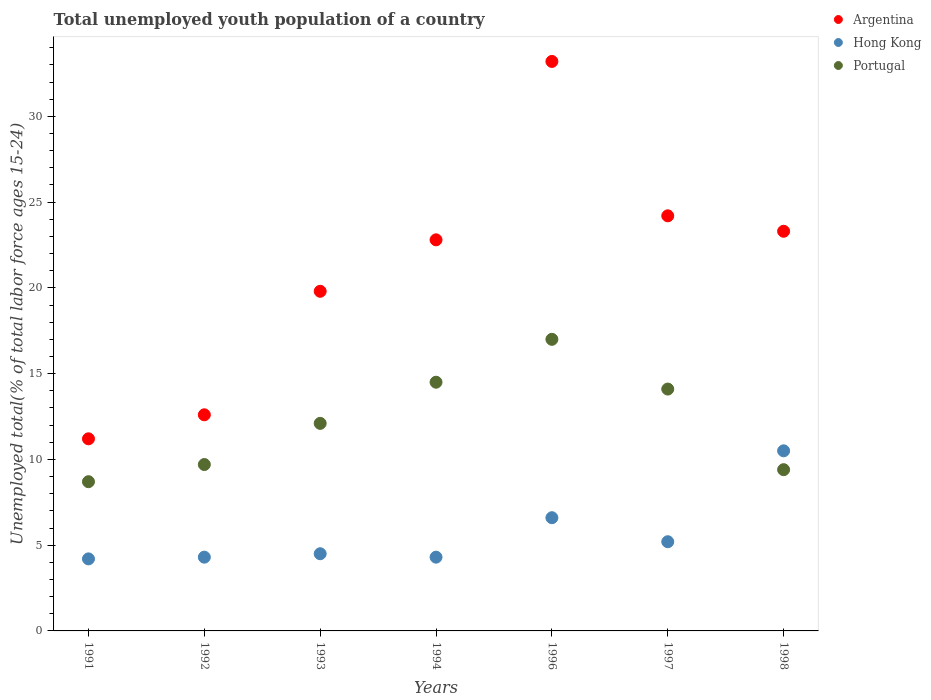How many different coloured dotlines are there?
Make the answer very short. 3. Is the number of dotlines equal to the number of legend labels?
Keep it short and to the point. Yes. What is the percentage of total unemployed youth population of a country in Argentina in 1992?
Offer a very short reply. 12.6. Across all years, what is the maximum percentage of total unemployed youth population of a country in Argentina?
Your response must be concise. 33.2. Across all years, what is the minimum percentage of total unemployed youth population of a country in Argentina?
Keep it short and to the point. 11.2. In which year was the percentage of total unemployed youth population of a country in Portugal maximum?
Provide a short and direct response. 1996. What is the total percentage of total unemployed youth population of a country in Portugal in the graph?
Your answer should be very brief. 85.5. What is the difference between the percentage of total unemployed youth population of a country in Argentina in 1992 and that in 1998?
Keep it short and to the point. -10.7. What is the difference between the percentage of total unemployed youth population of a country in Portugal in 1993 and the percentage of total unemployed youth population of a country in Hong Kong in 1996?
Offer a terse response. 5.5. What is the average percentage of total unemployed youth population of a country in Hong Kong per year?
Your response must be concise. 5.66. In the year 1997, what is the difference between the percentage of total unemployed youth population of a country in Hong Kong and percentage of total unemployed youth population of a country in Portugal?
Your response must be concise. -8.9. In how many years, is the percentage of total unemployed youth population of a country in Argentina greater than 11 %?
Give a very brief answer. 7. What is the ratio of the percentage of total unemployed youth population of a country in Argentina in 1994 to that in 1998?
Offer a terse response. 0.98. What is the difference between the highest and the second highest percentage of total unemployed youth population of a country in Argentina?
Provide a succinct answer. 9. What is the difference between the highest and the lowest percentage of total unemployed youth population of a country in Hong Kong?
Give a very brief answer. 6.3. In how many years, is the percentage of total unemployed youth population of a country in Portugal greater than the average percentage of total unemployed youth population of a country in Portugal taken over all years?
Your answer should be very brief. 3. Is the sum of the percentage of total unemployed youth population of a country in Portugal in 1992 and 1998 greater than the maximum percentage of total unemployed youth population of a country in Argentina across all years?
Provide a short and direct response. No. Is it the case that in every year, the sum of the percentage of total unemployed youth population of a country in Hong Kong and percentage of total unemployed youth population of a country in Portugal  is greater than the percentage of total unemployed youth population of a country in Argentina?
Provide a short and direct response. No. How many dotlines are there?
Offer a very short reply. 3. What is the difference between two consecutive major ticks on the Y-axis?
Provide a succinct answer. 5. Where does the legend appear in the graph?
Provide a short and direct response. Top right. What is the title of the graph?
Your answer should be compact. Total unemployed youth population of a country. What is the label or title of the X-axis?
Your response must be concise. Years. What is the label or title of the Y-axis?
Provide a short and direct response. Unemployed total(% of total labor force ages 15-24). What is the Unemployed total(% of total labor force ages 15-24) of Argentina in 1991?
Ensure brevity in your answer.  11.2. What is the Unemployed total(% of total labor force ages 15-24) in Hong Kong in 1991?
Ensure brevity in your answer.  4.2. What is the Unemployed total(% of total labor force ages 15-24) in Portugal in 1991?
Your answer should be compact. 8.7. What is the Unemployed total(% of total labor force ages 15-24) in Argentina in 1992?
Give a very brief answer. 12.6. What is the Unemployed total(% of total labor force ages 15-24) in Hong Kong in 1992?
Your answer should be very brief. 4.3. What is the Unemployed total(% of total labor force ages 15-24) of Portugal in 1992?
Offer a very short reply. 9.7. What is the Unemployed total(% of total labor force ages 15-24) in Argentina in 1993?
Give a very brief answer. 19.8. What is the Unemployed total(% of total labor force ages 15-24) of Portugal in 1993?
Make the answer very short. 12.1. What is the Unemployed total(% of total labor force ages 15-24) in Argentina in 1994?
Offer a terse response. 22.8. What is the Unemployed total(% of total labor force ages 15-24) of Hong Kong in 1994?
Your answer should be very brief. 4.3. What is the Unemployed total(% of total labor force ages 15-24) in Portugal in 1994?
Your answer should be very brief. 14.5. What is the Unemployed total(% of total labor force ages 15-24) of Argentina in 1996?
Offer a very short reply. 33.2. What is the Unemployed total(% of total labor force ages 15-24) of Hong Kong in 1996?
Provide a short and direct response. 6.6. What is the Unemployed total(% of total labor force ages 15-24) in Argentina in 1997?
Give a very brief answer. 24.2. What is the Unemployed total(% of total labor force ages 15-24) of Hong Kong in 1997?
Offer a very short reply. 5.2. What is the Unemployed total(% of total labor force ages 15-24) in Portugal in 1997?
Provide a succinct answer. 14.1. What is the Unemployed total(% of total labor force ages 15-24) of Argentina in 1998?
Ensure brevity in your answer.  23.3. What is the Unemployed total(% of total labor force ages 15-24) in Portugal in 1998?
Make the answer very short. 9.4. Across all years, what is the maximum Unemployed total(% of total labor force ages 15-24) of Argentina?
Your answer should be compact. 33.2. Across all years, what is the maximum Unemployed total(% of total labor force ages 15-24) of Hong Kong?
Your response must be concise. 10.5. Across all years, what is the maximum Unemployed total(% of total labor force ages 15-24) in Portugal?
Your response must be concise. 17. Across all years, what is the minimum Unemployed total(% of total labor force ages 15-24) in Argentina?
Give a very brief answer. 11.2. Across all years, what is the minimum Unemployed total(% of total labor force ages 15-24) in Hong Kong?
Your response must be concise. 4.2. Across all years, what is the minimum Unemployed total(% of total labor force ages 15-24) in Portugal?
Ensure brevity in your answer.  8.7. What is the total Unemployed total(% of total labor force ages 15-24) in Argentina in the graph?
Ensure brevity in your answer.  147.1. What is the total Unemployed total(% of total labor force ages 15-24) in Hong Kong in the graph?
Give a very brief answer. 39.6. What is the total Unemployed total(% of total labor force ages 15-24) of Portugal in the graph?
Provide a short and direct response. 85.5. What is the difference between the Unemployed total(% of total labor force ages 15-24) of Argentina in 1991 and that in 1992?
Provide a short and direct response. -1.4. What is the difference between the Unemployed total(% of total labor force ages 15-24) in Argentina in 1991 and that in 1993?
Provide a short and direct response. -8.6. What is the difference between the Unemployed total(% of total labor force ages 15-24) of Portugal in 1991 and that in 1993?
Make the answer very short. -3.4. What is the difference between the Unemployed total(% of total labor force ages 15-24) of Argentina in 1991 and that in 1994?
Your answer should be very brief. -11.6. What is the difference between the Unemployed total(% of total labor force ages 15-24) in Portugal in 1991 and that in 1994?
Offer a very short reply. -5.8. What is the difference between the Unemployed total(% of total labor force ages 15-24) of Argentina in 1991 and that in 1997?
Keep it short and to the point. -13. What is the difference between the Unemployed total(% of total labor force ages 15-24) in Portugal in 1991 and that in 1998?
Ensure brevity in your answer.  -0.7. What is the difference between the Unemployed total(% of total labor force ages 15-24) in Portugal in 1992 and that in 1993?
Provide a succinct answer. -2.4. What is the difference between the Unemployed total(% of total labor force ages 15-24) in Hong Kong in 1992 and that in 1994?
Offer a very short reply. 0. What is the difference between the Unemployed total(% of total labor force ages 15-24) in Argentina in 1992 and that in 1996?
Provide a short and direct response. -20.6. What is the difference between the Unemployed total(% of total labor force ages 15-24) in Hong Kong in 1992 and that in 1996?
Your answer should be very brief. -2.3. What is the difference between the Unemployed total(% of total labor force ages 15-24) of Portugal in 1992 and that in 1996?
Ensure brevity in your answer.  -7.3. What is the difference between the Unemployed total(% of total labor force ages 15-24) in Argentina in 1992 and that in 1997?
Provide a short and direct response. -11.6. What is the difference between the Unemployed total(% of total labor force ages 15-24) of Argentina in 1992 and that in 1998?
Keep it short and to the point. -10.7. What is the difference between the Unemployed total(% of total labor force ages 15-24) in Hong Kong in 1992 and that in 1998?
Offer a very short reply. -6.2. What is the difference between the Unemployed total(% of total labor force ages 15-24) in Portugal in 1992 and that in 1998?
Your response must be concise. 0.3. What is the difference between the Unemployed total(% of total labor force ages 15-24) in Argentina in 1993 and that in 1994?
Offer a terse response. -3. What is the difference between the Unemployed total(% of total labor force ages 15-24) in Argentina in 1993 and that in 1996?
Your answer should be compact. -13.4. What is the difference between the Unemployed total(% of total labor force ages 15-24) in Portugal in 1993 and that in 1996?
Offer a terse response. -4.9. What is the difference between the Unemployed total(% of total labor force ages 15-24) of Hong Kong in 1993 and that in 1997?
Provide a succinct answer. -0.7. What is the difference between the Unemployed total(% of total labor force ages 15-24) of Hong Kong in 1993 and that in 1998?
Your response must be concise. -6. What is the difference between the Unemployed total(% of total labor force ages 15-24) of Hong Kong in 1994 and that in 1996?
Your answer should be very brief. -2.3. What is the difference between the Unemployed total(% of total labor force ages 15-24) of Hong Kong in 1994 and that in 1997?
Your response must be concise. -0.9. What is the difference between the Unemployed total(% of total labor force ages 15-24) in Argentina in 1994 and that in 1998?
Ensure brevity in your answer.  -0.5. What is the difference between the Unemployed total(% of total labor force ages 15-24) in Hong Kong in 1994 and that in 1998?
Provide a short and direct response. -6.2. What is the difference between the Unemployed total(% of total labor force ages 15-24) of Argentina in 1996 and that in 1998?
Provide a short and direct response. 9.9. What is the difference between the Unemployed total(% of total labor force ages 15-24) of Hong Kong in 1996 and that in 1998?
Provide a succinct answer. -3.9. What is the difference between the Unemployed total(% of total labor force ages 15-24) in Argentina in 1997 and that in 1998?
Provide a short and direct response. 0.9. What is the difference between the Unemployed total(% of total labor force ages 15-24) of Hong Kong in 1991 and the Unemployed total(% of total labor force ages 15-24) of Portugal in 1992?
Your answer should be very brief. -5.5. What is the difference between the Unemployed total(% of total labor force ages 15-24) in Argentina in 1991 and the Unemployed total(% of total labor force ages 15-24) in Portugal in 1993?
Make the answer very short. -0.9. What is the difference between the Unemployed total(% of total labor force ages 15-24) of Argentina in 1991 and the Unemployed total(% of total labor force ages 15-24) of Hong Kong in 1994?
Give a very brief answer. 6.9. What is the difference between the Unemployed total(% of total labor force ages 15-24) of Argentina in 1991 and the Unemployed total(% of total labor force ages 15-24) of Hong Kong in 1997?
Make the answer very short. 6. What is the difference between the Unemployed total(% of total labor force ages 15-24) of Argentina in 1991 and the Unemployed total(% of total labor force ages 15-24) of Portugal in 1998?
Your answer should be very brief. 1.8. What is the difference between the Unemployed total(% of total labor force ages 15-24) of Hong Kong in 1991 and the Unemployed total(% of total labor force ages 15-24) of Portugal in 1998?
Ensure brevity in your answer.  -5.2. What is the difference between the Unemployed total(% of total labor force ages 15-24) of Argentina in 1992 and the Unemployed total(% of total labor force ages 15-24) of Portugal in 1996?
Offer a very short reply. -4.4. What is the difference between the Unemployed total(% of total labor force ages 15-24) of Hong Kong in 1992 and the Unemployed total(% of total labor force ages 15-24) of Portugal in 1996?
Your response must be concise. -12.7. What is the difference between the Unemployed total(% of total labor force ages 15-24) in Argentina in 1992 and the Unemployed total(% of total labor force ages 15-24) in Hong Kong in 1997?
Offer a terse response. 7.4. What is the difference between the Unemployed total(% of total labor force ages 15-24) of Argentina in 1992 and the Unemployed total(% of total labor force ages 15-24) of Portugal in 1997?
Your response must be concise. -1.5. What is the difference between the Unemployed total(% of total labor force ages 15-24) of Hong Kong in 1992 and the Unemployed total(% of total labor force ages 15-24) of Portugal in 1997?
Your answer should be very brief. -9.8. What is the difference between the Unemployed total(% of total labor force ages 15-24) in Argentina in 1992 and the Unemployed total(% of total labor force ages 15-24) in Hong Kong in 1998?
Provide a succinct answer. 2.1. What is the difference between the Unemployed total(% of total labor force ages 15-24) of Argentina in 1992 and the Unemployed total(% of total labor force ages 15-24) of Portugal in 1998?
Give a very brief answer. 3.2. What is the difference between the Unemployed total(% of total labor force ages 15-24) in Argentina in 1993 and the Unemployed total(% of total labor force ages 15-24) in Hong Kong in 1994?
Your response must be concise. 15.5. What is the difference between the Unemployed total(% of total labor force ages 15-24) of Argentina in 1993 and the Unemployed total(% of total labor force ages 15-24) of Hong Kong in 1996?
Your answer should be very brief. 13.2. What is the difference between the Unemployed total(% of total labor force ages 15-24) in Hong Kong in 1993 and the Unemployed total(% of total labor force ages 15-24) in Portugal in 1996?
Your answer should be compact. -12.5. What is the difference between the Unemployed total(% of total labor force ages 15-24) in Argentina in 1993 and the Unemployed total(% of total labor force ages 15-24) in Portugal in 1997?
Ensure brevity in your answer.  5.7. What is the difference between the Unemployed total(% of total labor force ages 15-24) of Hong Kong in 1993 and the Unemployed total(% of total labor force ages 15-24) of Portugal in 1997?
Offer a terse response. -9.6. What is the difference between the Unemployed total(% of total labor force ages 15-24) in Argentina in 1993 and the Unemployed total(% of total labor force ages 15-24) in Hong Kong in 1998?
Give a very brief answer. 9.3. What is the difference between the Unemployed total(% of total labor force ages 15-24) of Argentina in 1993 and the Unemployed total(% of total labor force ages 15-24) of Portugal in 1998?
Offer a terse response. 10.4. What is the difference between the Unemployed total(% of total labor force ages 15-24) in Hong Kong in 1993 and the Unemployed total(% of total labor force ages 15-24) in Portugal in 1998?
Provide a short and direct response. -4.9. What is the difference between the Unemployed total(% of total labor force ages 15-24) in Argentina in 1994 and the Unemployed total(% of total labor force ages 15-24) in Hong Kong in 1996?
Ensure brevity in your answer.  16.2. What is the difference between the Unemployed total(% of total labor force ages 15-24) of Hong Kong in 1994 and the Unemployed total(% of total labor force ages 15-24) of Portugal in 1996?
Ensure brevity in your answer.  -12.7. What is the difference between the Unemployed total(% of total labor force ages 15-24) in Argentina in 1994 and the Unemployed total(% of total labor force ages 15-24) in Hong Kong in 1997?
Provide a short and direct response. 17.6. What is the difference between the Unemployed total(% of total labor force ages 15-24) of Argentina in 1994 and the Unemployed total(% of total labor force ages 15-24) of Portugal in 1997?
Offer a very short reply. 8.7. What is the difference between the Unemployed total(% of total labor force ages 15-24) in Argentina in 1994 and the Unemployed total(% of total labor force ages 15-24) in Hong Kong in 1998?
Offer a terse response. 12.3. What is the difference between the Unemployed total(% of total labor force ages 15-24) of Argentina in 1994 and the Unemployed total(% of total labor force ages 15-24) of Portugal in 1998?
Keep it short and to the point. 13.4. What is the difference between the Unemployed total(% of total labor force ages 15-24) in Hong Kong in 1996 and the Unemployed total(% of total labor force ages 15-24) in Portugal in 1997?
Ensure brevity in your answer.  -7.5. What is the difference between the Unemployed total(% of total labor force ages 15-24) in Argentina in 1996 and the Unemployed total(% of total labor force ages 15-24) in Hong Kong in 1998?
Your answer should be compact. 22.7. What is the difference between the Unemployed total(% of total labor force ages 15-24) of Argentina in 1996 and the Unemployed total(% of total labor force ages 15-24) of Portugal in 1998?
Your answer should be very brief. 23.8. What is the difference between the Unemployed total(% of total labor force ages 15-24) of Argentina in 1997 and the Unemployed total(% of total labor force ages 15-24) of Hong Kong in 1998?
Offer a very short reply. 13.7. What is the difference between the Unemployed total(% of total labor force ages 15-24) of Argentina in 1997 and the Unemployed total(% of total labor force ages 15-24) of Portugal in 1998?
Keep it short and to the point. 14.8. What is the difference between the Unemployed total(% of total labor force ages 15-24) of Hong Kong in 1997 and the Unemployed total(% of total labor force ages 15-24) of Portugal in 1998?
Keep it short and to the point. -4.2. What is the average Unemployed total(% of total labor force ages 15-24) in Argentina per year?
Provide a short and direct response. 21.01. What is the average Unemployed total(% of total labor force ages 15-24) in Hong Kong per year?
Ensure brevity in your answer.  5.66. What is the average Unemployed total(% of total labor force ages 15-24) in Portugal per year?
Offer a terse response. 12.21. In the year 1991, what is the difference between the Unemployed total(% of total labor force ages 15-24) in Argentina and Unemployed total(% of total labor force ages 15-24) in Hong Kong?
Provide a succinct answer. 7. In the year 1991, what is the difference between the Unemployed total(% of total labor force ages 15-24) in Hong Kong and Unemployed total(% of total labor force ages 15-24) in Portugal?
Keep it short and to the point. -4.5. In the year 1992, what is the difference between the Unemployed total(% of total labor force ages 15-24) of Argentina and Unemployed total(% of total labor force ages 15-24) of Hong Kong?
Provide a succinct answer. 8.3. In the year 1993, what is the difference between the Unemployed total(% of total labor force ages 15-24) of Argentina and Unemployed total(% of total labor force ages 15-24) of Hong Kong?
Provide a short and direct response. 15.3. In the year 1994, what is the difference between the Unemployed total(% of total labor force ages 15-24) in Argentina and Unemployed total(% of total labor force ages 15-24) in Hong Kong?
Keep it short and to the point. 18.5. In the year 1996, what is the difference between the Unemployed total(% of total labor force ages 15-24) of Argentina and Unemployed total(% of total labor force ages 15-24) of Hong Kong?
Offer a terse response. 26.6. In the year 1997, what is the difference between the Unemployed total(% of total labor force ages 15-24) of Argentina and Unemployed total(% of total labor force ages 15-24) of Hong Kong?
Give a very brief answer. 19. In the year 1997, what is the difference between the Unemployed total(% of total labor force ages 15-24) of Argentina and Unemployed total(% of total labor force ages 15-24) of Portugal?
Your answer should be compact. 10.1. In the year 1997, what is the difference between the Unemployed total(% of total labor force ages 15-24) in Hong Kong and Unemployed total(% of total labor force ages 15-24) in Portugal?
Your response must be concise. -8.9. In the year 1998, what is the difference between the Unemployed total(% of total labor force ages 15-24) in Hong Kong and Unemployed total(% of total labor force ages 15-24) in Portugal?
Keep it short and to the point. 1.1. What is the ratio of the Unemployed total(% of total labor force ages 15-24) of Argentina in 1991 to that in 1992?
Provide a short and direct response. 0.89. What is the ratio of the Unemployed total(% of total labor force ages 15-24) in Hong Kong in 1991 to that in 1992?
Provide a succinct answer. 0.98. What is the ratio of the Unemployed total(% of total labor force ages 15-24) of Portugal in 1991 to that in 1992?
Your answer should be very brief. 0.9. What is the ratio of the Unemployed total(% of total labor force ages 15-24) of Argentina in 1991 to that in 1993?
Provide a succinct answer. 0.57. What is the ratio of the Unemployed total(% of total labor force ages 15-24) in Portugal in 1991 to that in 1993?
Provide a succinct answer. 0.72. What is the ratio of the Unemployed total(% of total labor force ages 15-24) in Argentina in 1991 to that in 1994?
Make the answer very short. 0.49. What is the ratio of the Unemployed total(% of total labor force ages 15-24) of Hong Kong in 1991 to that in 1994?
Offer a very short reply. 0.98. What is the ratio of the Unemployed total(% of total labor force ages 15-24) of Portugal in 1991 to that in 1994?
Offer a very short reply. 0.6. What is the ratio of the Unemployed total(% of total labor force ages 15-24) in Argentina in 1991 to that in 1996?
Make the answer very short. 0.34. What is the ratio of the Unemployed total(% of total labor force ages 15-24) of Hong Kong in 1991 to that in 1996?
Ensure brevity in your answer.  0.64. What is the ratio of the Unemployed total(% of total labor force ages 15-24) of Portugal in 1991 to that in 1996?
Make the answer very short. 0.51. What is the ratio of the Unemployed total(% of total labor force ages 15-24) of Argentina in 1991 to that in 1997?
Provide a short and direct response. 0.46. What is the ratio of the Unemployed total(% of total labor force ages 15-24) in Hong Kong in 1991 to that in 1997?
Provide a short and direct response. 0.81. What is the ratio of the Unemployed total(% of total labor force ages 15-24) of Portugal in 1991 to that in 1997?
Make the answer very short. 0.62. What is the ratio of the Unemployed total(% of total labor force ages 15-24) of Argentina in 1991 to that in 1998?
Provide a short and direct response. 0.48. What is the ratio of the Unemployed total(% of total labor force ages 15-24) in Portugal in 1991 to that in 1998?
Keep it short and to the point. 0.93. What is the ratio of the Unemployed total(% of total labor force ages 15-24) of Argentina in 1992 to that in 1993?
Make the answer very short. 0.64. What is the ratio of the Unemployed total(% of total labor force ages 15-24) in Hong Kong in 1992 to that in 1993?
Make the answer very short. 0.96. What is the ratio of the Unemployed total(% of total labor force ages 15-24) of Portugal in 1992 to that in 1993?
Offer a terse response. 0.8. What is the ratio of the Unemployed total(% of total labor force ages 15-24) in Argentina in 1992 to that in 1994?
Your answer should be compact. 0.55. What is the ratio of the Unemployed total(% of total labor force ages 15-24) of Portugal in 1992 to that in 1994?
Provide a short and direct response. 0.67. What is the ratio of the Unemployed total(% of total labor force ages 15-24) of Argentina in 1992 to that in 1996?
Offer a very short reply. 0.38. What is the ratio of the Unemployed total(% of total labor force ages 15-24) in Hong Kong in 1992 to that in 1996?
Your response must be concise. 0.65. What is the ratio of the Unemployed total(% of total labor force ages 15-24) in Portugal in 1992 to that in 1996?
Offer a terse response. 0.57. What is the ratio of the Unemployed total(% of total labor force ages 15-24) in Argentina in 1992 to that in 1997?
Your answer should be very brief. 0.52. What is the ratio of the Unemployed total(% of total labor force ages 15-24) of Hong Kong in 1992 to that in 1997?
Give a very brief answer. 0.83. What is the ratio of the Unemployed total(% of total labor force ages 15-24) in Portugal in 1992 to that in 1997?
Your answer should be compact. 0.69. What is the ratio of the Unemployed total(% of total labor force ages 15-24) of Argentina in 1992 to that in 1998?
Offer a terse response. 0.54. What is the ratio of the Unemployed total(% of total labor force ages 15-24) of Hong Kong in 1992 to that in 1998?
Offer a very short reply. 0.41. What is the ratio of the Unemployed total(% of total labor force ages 15-24) in Portugal in 1992 to that in 1998?
Provide a short and direct response. 1.03. What is the ratio of the Unemployed total(% of total labor force ages 15-24) in Argentina in 1993 to that in 1994?
Provide a succinct answer. 0.87. What is the ratio of the Unemployed total(% of total labor force ages 15-24) of Hong Kong in 1993 to that in 1994?
Make the answer very short. 1.05. What is the ratio of the Unemployed total(% of total labor force ages 15-24) of Portugal in 1993 to that in 1994?
Provide a short and direct response. 0.83. What is the ratio of the Unemployed total(% of total labor force ages 15-24) of Argentina in 1993 to that in 1996?
Provide a succinct answer. 0.6. What is the ratio of the Unemployed total(% of total labor force ages 15-24) of Hong Kong in 1993 to that in 1996?
Give a very brief answer. 0.68. What is the ratio of the Unemployed total(% of total labor force ages 15-24) of Portugal in 1993 to that in 1996?
Offer a very short reply. 0.71. What is the ratio of the Unemployed total(% of total labor force ages 15-24) of Argentina in 1993 to that in 1997?
Provide a short and direct response. 0.82. What is the ratio of the Unemployed total(% of total labor force ages 15-24) in Hong Kong in 1993 to that in 1997?
Provide a succinct answer. 0.87. What is the ratio of the Unemployed total(% of total labor force ages 15-24) in Portugal in 1993 to that in 1997?
Give a very brief answer. 0.86. What is the ratio of the Unemployed total(% of total labor force ages 15-24) in Argentina in 1993 to that in 1998?
Your response must be concise. 0.85. What is the ratio of the Unemployed total(% of total labor force ages 15-24) of Hong Kong in 1993 to that in 1998?
Offer a terse response. 0.43. What is the ratio of the Unemployed total(% of total labor force ages 15-24) of Portugal in 1993 to that in 1998?
Offer a very short reply. 1.29. What is the ratio of the Unemployed total(% of total labor force ages 15-24) of Argentina in 1994 to that in 1996?
Ensure brevity in your answer.  0.69. What is the ratio of the Unemployed total(% of total labor force ages 15-24) in Hong Kong in 1994 to that in 1996?
Make the answer very short. 0.65. What is the ratio of the Unemployed total(% of total labor force ages 15-24) of Portugal in 1994 to that in 1996?
Provide a short and direct response. 0.85. What is the ratio of the Unemployed total(% of total labor force ages 15-24) in Argentina in 1994 to that in 1997?
Give a very brief answer. 0.94. What is the ratio of the Unemployed total(% of total labor force ages 15-24) of Hong Kong in 1994 to that in 1997?
Offer a very short reply. 0.83. What is the ratio of the Unemployed total(% of total labor force ages 15-24) in Portugal in 1994 to that in 1997?
Your response must be concise. 1.03. What is the ratio of the Unemployed total(% of total labor force ages 15-24) in Argentina in 1994 to that in 1998?
Make the answer very short. 0.98. What is the ratio of the Unemployed total(% of total labor force ages 15-24) of Hong Kong in 1994 to that in 1998?
Your response must be concise. 0.41. What is the ratio of the Unemployed total(% of total labor force ages 15-24) in Portugal in 1994 to that in 1998?
Give a very brief answer. 1.54. What is the ratio of the Unemployed total(% of total labor force ages 15-24) in Argentina in 1996 to that in 1997?
Your response must be concise. 1.37. What is the ratio of the Unemployed total(% of total labor force ages 15-24) of Hong Kong in 1996 to that in 1997?
Provide a succinct answer. 1.27. What is the ratio of the Unemployed total(% of total labor force ages 15-24) of Portugal in 1996 to that in 1997?
Your answer should be compact. 1.21. What is the ratio of the Unemployed total(% of total labor force ages 15-24) of Argentina in 1996 to that in 1998?
Your answer should be compact. 1.42. What is the ratio of the Unemployed total(% of total labor force ages 15-24) in Hong Kong in 1996 to that in 1998?
Offer a very short reply. 0.63. What is the ratio of the Unemployed total(% of total labor force ages 15-24) in Portugal in 1996 to that in 1998?
Provide a short and direct response. 1.81. What is the ratio of the Unemployed total(% of total labor force ages 15-24) in Argentina in 1997 to that in 1998?
Keep it short and to the point. 1.04. What is the ratio of the Unemployed total(% of total labor force ages 15-24) in Hong Kong in 1997 to that in 1998?
Ensure brevity in your answer.  0.5. What is the ratio of the Unemployed total(% of total labor force ages 15-24) in Portugal in 1997 to that in 1998?
Make the answer very short. 1.5. What is the difference between the highest and the second highest Unemployed total(% of total labor force ages 15-24) of Hong Kong?
Give a very brief answer. 3.9. What is the difference between the highest and the second highest Unemployed total(% of total labor force ages 15-24) of Portugal?
Offer a terse response. 2.5. What is the difference between the highest and the lowest Unemployed total(% of total labor force ages 15-24) of Argentina?
Provide a succinct answer. 22. What is the difference between the highest and the lowest Unemployed total(% of total labor force ages 15-24) of Hong Kong?
Provide a short and direct response. 6.3. 